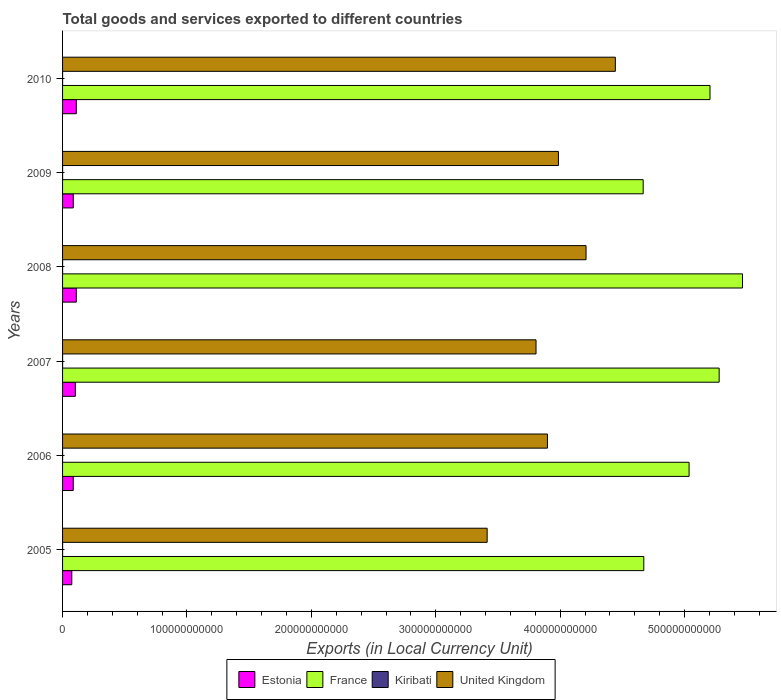How many groups of bars are there?
Give a very brief answer. 6. Are the number of bars per tick equal to the number of legend labels?
Ensure brevity in your answer.  Yes. Are the number of bars on each tick of the Y-axis equal?
Provide a succinct answer. Yes. In how many cases, is the number of bars for a given year not equal to the number of legend labels?
Provide a succinct answer. 0. What is the Amount of goods and services exports in Kiribati in 2009?
Provide a short and direct response. 2.34e+07. Across all years, what is the maximum Amount of goods and services exports in France?
Offer a terse response. 5.47e+11. Across all years, what is the minimum Amount of goods and services exports in Kiribati?
Make the answer very short. 1.52e+07. In which year was the Amount of goods and services exports in United Kingdom maximum?
Give a very brief answer. 2010. What is the total Amount of goods and services exports in Kiribati in the graph?
Make the answer very short. 1.23e+08. What is the difference between the Amount of goods and services exports in United Kingdom in 2005 and that in 2009?
Make the answer very short. -5.73e+1. What is the difference between the Amount of goods and services exports in Kiribati in 2006 and the Amount of goods and services exports in France in 2007?
Give a very brief answer. -5.28e+11. What is the average Amount of goods and services exports in Estonia per year?
Your answer should be compact. 9.49e+09. In the year 2010, what is the difference between the Amount of goods and services exports in Estonia and Amount of goods and services exports in France?
Ensure brevity in your answer.  -5.09e+11. In how many years, is the Amount of goods and services exports in Kiribati greater than 220000000000 LCU?
Offer a very short reply. 0. What is the ratio of the Amount of goods and services exports in Estonia in 2008 to that in 2010?
Offer a terse response. 1. Is the Amount of goods and services exports in United Kingdom in 2007 less than that in 2010?
Keep it short and to the point. Yes. What is the difference between the highest and the second highest Amount of goods and services exports in Kiribati?
Your answer should be very brief. 1.50e+06. What is the difference between the highest and the lowest Amount of goods and services exports in France?
Give a very brief answer. 7.98e+1. In how many years, is the Amount of goods and services exports in United Kingdom greater than the average Amount of goods and services exports in United Kingdom taken over all years?
Your answer should be compact. 3. Is it the case that in every year, the sum of the Amount of goods and services exports in Estonia and Amount of goods and services exports in United Kingdom is greater than the sum of Amount of goods and services exports in Kiribati and Amount of goods and services exports in France?
Make the answer very short. No. What does the 2nd bar from the top in 2006 represents?
Keep it short and to the point. Kiribati. What does the 1st bar from the bottom in 2008 represents?
Make the answer very short. Estonia. How many years are there in the graph?
Make the answer very short. 6. What is the difference between two consecutive major ticks on the X-axis?
Your response must be concise. 1.00e+11. Are the values on the major ticks of X-axis written in scientific E-notation?
Give a very brief answer. No. Does the graph contain any zero values?
Offer a terse response. No. Does the graph contain grids?
Make the answer very short. No. How are the legend labels stacked?
Provide a succinct answer. Horizontal. What is the title of the graph?
Make the answer very short. Total goods and services exported to different countries. What is the label or title of the X-axis?
Keep it short and to the point. Exports (in Local Currency Unit). What is the label or title of the Y-axis?
Your answer should be compact. Years. What is the Exports (in Local Currency Unit) of Estonia in 2005?
Your answer should be very brief. 7.42e+09. What is the Exports (in Local Currency Unit) in France in 2005?
Your answer should be compact. 4.67e+11. What is the Exports (in Local Currency Unit) of Kiribati in 2005?
Your answer should be very brief. 1.96e+07. What is the Exports (in Local Currency Unit) of United Kingdom in 2005?
Provide a succinct answer. 3.41e+11. What is the Exports (in Local Currency Unit) in Estonia in 2006?
Ensure brevity in your answer.  8.58e+09. What is the Exports (in Local Currency Unit) of France in 2006?
Offer a very short reply. 5.04e+11. What is the Exports (in Local Currency Unit) in Kiribati in 2006?
Ensure brevity in your answer.  1.52e+07. What is the Exports (in Local Currency Unit) in United Kingdom in 2006?
Your answer should be very brief. 3.90e+11. What is the Exports (in Local Currency Unit) of Estonia in 2007?
Provide a succinct answer. 1.03e+1. What is the Exports (in Local Currency Unit) of France in 2007?
Your answer should be compact. 5.28e+11. What is the Exports (in Local Currency Unit) in Kiribati in 2007?
Your answer should be very brief. 2.49e+07. What is the Exports (in Local Currency Unit) in United Kingdom in 2007?
Your answer should be very brief. 3.81e+11. What is the Exports (in Local Currency Unit) of Estonia in 2008?
Make the answer very short. 1.10e+1. What is the Exports (in Local Currency Unit) of France in 2008?
Your answer should be compact. 5.47e+11. What is the Exports (in Local Currency Unit) in Kiribati in 2008?
Your answer should be compact. 2.26e+07. What is the Exports (in Local Currency Unit) in United Kingdom in 2008?
Your answer should be very brief. 4.21e+11. What is the Exports (in Local Currency Unit) of Estonia in 2009?
Offer a terse response. 8.60e+09. What is the Exports (in Local Currency Unit) of France in 2009?
Offer a terse response. 4.67e+11. What is the Exports (in Local Currency Unit) in Kiribati in 2009?
Offer a very short reply. 2.34e+07. What is the Exports (in Local Currency Unit) in United Kingdom in 2009?
Your answer should be compact. 3.99e+11. What is the Exports (in Local Currency Unit) of Estonia in 2010?
Keep it short and to the point. 1.10e+1. What is the Exports (in Local Currency Unit) of France in 2010?
Ensure brevity in your answer.  5.20e+11. What is the Exports (in Local Currency Unit) in Kiribati in 2010?
Offer a terse response. 1.78e+07. What is the Exports (in Local Currency Unit) in United Kingdom in 2010?
Offer a terse response. 4.44e+11. Across all years, what is the maximum Exports (in Local Currency Unit) of Estonia?
Keep it short and to the point. 1.10e+1. Across all years, what is the maximum Exports (in Local Currency Unit) in France?
Provide a short and direct response. 5.47e+11. Across all years, what is the maximum Exports (in Local Currency Unit) in Kiribati?
Make the answer very short. 2.49e+07. Across all years, what is the maximum Exports (in Local Currency Unit) of United Kingdom?
Give a very brief answer. 4.44e+11. Across all years, what is the minimum Exports (in Local Currency Unit) of Estonia?
Ensure brevity in your answer.  7.42e+09. Across all years, what is the minimum Exports (in Local Currency Unit) of France?
Ensure brevity in your answer.  4.67e+11. Across all years, what is the minimum Exports (in Local Currency Unit) of Kiribati?
Provide a short and direct response. 1.52e+07. Across all years, what is the minimum Exports (in Local Currency Unit) of United Kingdom?
Offer a terse response. 3.41e+11. What is the total Exports (in Local Currency Unit) of Estonia in the graph?
Provide a short and direct response. 5.70e+1. What is the total Exports (in Local Currency Unit) in France in the graph?
Provide a short and direct response. 3.03e+12. What is the total Exports (in Local Currency Unit) of Kiribati in the graph?
Your answer should be compact. 1.23e+08. What is the total Exports (in Local Currency Unit) in United Kingdom in the graph?
Provide a short and direct response. 2.38e+12. What is the difference between the Exports (in Local Currency Unit) in Estonia in 2005 and that in 2006?
Your answer should be compact. -1.16e+09. What is the difference between the Exports (in Local Currency Unit) in France in 2005 and that in 2006?
Make the answer very short. -3.64e+1. What is the difference between the Exports (in Local Currency Unit) in Kiribati in 2005 and that in 2006?
Your response must be concise. 4.42e+06. What is the difference between the Exports (in Local Currency Unit) of United Kingdom in 2005 and that in 2006?
Offer a very short reply. -4.85e+1. What is the difference between the Exports (in Local Currency Unit) in Estonia in 2005 and that in 2007?
Ensure brevity in your answer.  -2.84e+09. What is the difference between the Exports (in Local Currency Unit) of France in 2005 and that in 2007?
Your answer should be compact. -6.06e+1. What is the difference between the Exports (in Local Currency Unit) in Kiribati in 2005 and that in 2007?
Offer a very short reply. -5.27e+06. What is the difference between the Exports (in Local Currency Unit) of United Kingdom in 2005 and that in 2007?
Make the answer very short. -3.93e+1. What is the difference between the Exports (in Local Currency Unit) of Estonia in 2005 and that in 2008?
Your answer should be compact. -3.61e+09. What is the difference between the Exports (in Local Currency Unit) in France in 2005 and that in 2008?
Your response must be concise. -7.93e+1. What is the difference between the Exports (in Local Currency Unit) of Kiribati in 2005 and that in 2008?
Provide a short and direct response. -3.04e+06. What is the difference between the Exports (in Local Currency Unit) in United Kingdom in 2005 and that in 2008?
Give a very brief answer. -7.95e+1. What is the difference between the Exports (in Local Currency Unit) in Estonia in 2005 and that in 2009?
Ensure brevity in your answer.  -1.18e+09. What is the difference between the Exports (in Local Currency Unit) in France in 2005 and that in 2009?
Your response must be concise. 4.97e+08. What is the difference between the Exports (in Local Currency Unit) in Kiribati in 2005 and that in 2009?
Ensure brevity in your answer.  -3.77e+06. What is the difference between the Exports (in Local Currency Unit) of United Kingdom in 2005 and that in 2009?
Your answer should be compact. -5.73e+1. What is the difference between the Exports (in Local Currency Unit) in Estonia in 2005 and that in 2010?
Your response must be concise. -3.63e+09. What is the difference between the Exports (in Local Currency Unit) of France in 2005 and that in 2010?
Your answer should be very brief. -5.32e+1. What is the difference between the Exports (in Local Currency Unit) of Kiribati in 2005 and that in 2010?
Provide a short and direct response. 1.81e+06. What is the difference between the Exports (in Local Currency Unit) in United Kingdom in 2005 and that in 2010?
Offer a very short reply. -1.03e+11. What is the difference between the Exports (in Local Currency Unit) of Estonia in 2006 and that in 2007?
Your answer should be compact. -1.68e+09. What is the difference between the Exports (in Local Currency Unit) in France in 2006 and that in 2007?
Ensure brevity in your answer.  -2.42e+1. What is the difference between the Exports (in Local Currency Unit) in Kiribati in 2006 and that in 2007?
Provide a succinct answer. -9.69e+06. What is the difference between the Exports (in Local Currency Unit) of United Kingdom in 2006 and that in 2007?
Provide a short and direct response. 9.18e+09. What is the difference between the Exports (in Local Currency Unit) of Estonia in 2006 and that in 2008?
Keep it short and to the point. -2.45e+09. What is the difference between the Exports (in Local Currency Unit) in France in 2006 and that in 2008?
Your response must be concise. -4.29e+1. What is the difference between the Exports (in Local Currency Unit) in Kiribati in 2006 and that in 2008?
Make the answer very short. -7.46e+06. What is the difference between the Exports (in Local Currency Unit) in United Kingdom in 2006 and that in 2008?
Your response must be concise. -3.10e+1. What is the difference between the Exports (in Local Currency Unit) of Estonia in 2006 and that in 2009?
Offer a terse response. -1.66e+07. What is the difference between the Exports (in Local Currency Unit) in France in 2006 and that in 2009?
Offer a very short reply. 3.69e+1. What is the difference between the Exports (in Local Currency Unit) of Kiribati in 2006 and that in 2009?
Offer a very short reply. -8.19e+06. What is the difference between the Exports (in Local Currency Unit) of United Kingdom in 2006 and that in 2009?
Your answer should be compact. -8.82e+09. What is the difference between the Exports (in Local Currency Unit) of Estonia in 2006 and that in 2010?
Keep it short and to the point. -2.46e+09. What is the difference between the Exports (in Local Currency Unit) in France in 2006 and that in 2010?
Your answer should be very brief. -1.68e+1. What is the difference between the Exports (in Local Currency Unit) of Kiribati in 2006 and that in 2010?
Offer a very short reply. -2.62e+06. What is the difference between the Exports (in Local Currency Unit) of United Kingdom in 2006 and that in 2010?
Provide a short and direct response. -5.46e+1. What is the difference between the Exports (in Local Currency Unit) in Estonia in 2007 and that in 2008?
Make the answer very short. -7.66e+08. What is the difference between the Exports (in Local Currency Unit) in France in 2007 and that in 2008?
Provide a short and direct response. -1.88e+1. What is the difference between the Exports (in Local Currency Unit) in Kiribati in 2007 and that in 2008?
Offer a very short reply. 2.23e+06. What is the difference between the Exports (in Local Currency Unit) of United Kingdom in 2007 and that in 2008?
Offer a terse response. -4.02e+1. What is the difference between the Exports (in Local Currency Unit) of Estonia in 2007 and that in 2009?
Make the answer very short. 1.67e+09. What is the difference between the Exports (in Local Currency Unit) in France in 2007 and that in 2009?
Your response must be concise. 6.11e+1. What is the difference between the Exports (in Local Currency Unit) in Kiribati in 2007 and that in 2009?
Give a very brief answer. 1.50e+06. What is the difference between the Exports (in Local Currency Unit) of United Kingdom in 2007 and that in 2009?
Give a very brief answer. -1.80e+1. What is the difference between the Exports (in Local Currency Unit) of Estonia in 2007 and that in 2010?
Your answer should be very brief. -7.82e+08. What is the difference between the Exports (in Local Currency Unit) in France in 2007 and that in 2010?
Provide a short and direct response. 7.36e+09. What is the difference between the Exports (in Local Currency Unit) of Kiribati in 2007 and that in 2010?
Give a very brief answer. 7.08e+06. What is the difference between the Exports (in Local Currency Unit) of United Kingdom in 2007 and that in 2010?
Your answer should be compact. -6.38e+1. What is the difference between the Exports (in Local Currency Unit) of Estonia in 2008 and that in 2009?
Give a very brief answer. 2.43e+09. What is the difference between the Exports (in Local Currency Unit) of France in 2008 and that in 2009?
Offer a very short reply. 7.98e+1. What is the difference between the Exports (in Local Currency Unit) in Kiribati in 2008 and that in 2009?
Provide a short and direct response. -7.25e+05. What is the difference between the Exports (in Local Currency Unit) of United Kingdom in 2008 and that in 2009?
Provide a succinct answer. 2.22e+1. What is the difference between the Exports (in Local Currency Unit) in Estonia in 2008 and that in 2010?
Your response must be concise. -1.58e+07. What is the difference between the Exports (in Local Currency Unit) in France in 2008 and that in 2010?
Ensure brevity in your answer.  2.61e+1. What is the difference between the Exports (in Local Currency Unit) in Kiribati in 2008 and that in 2010?
Your answer should be compact. 4.85e+06. What is the difference between the Exports (in Local Currency Unit) of United Kingdom in 2008 and that in 2010?
Provide a succinct answer. -2.36e+1. What is the difference between the Exports (in Local Currency Unit) in Estonia in 2009 and that in 2010?
Make the answer very short. -2.45e+09. What is the difference between the Exports (in Local Currency Unit) in France in 2009 and that in 2010?
Offer a very short reply. -5.37e+1. What is the difference between the Exports (in Local Currency Unit) in Kiribati in 2009 and that in 2010?
Ensure brevity in your answer.  5.57e+06. What is the difference between the Exports (in Local Currency Unit) in United Kingdom in 2009 and that in 2010?
Make the answer very short. -4.58e+1. What is the difference between the Exports (in Local Currency Unit) of Estonia in 2005 and the Exports (in Local Currency Unit) of France in 2006?
Make the answer very short. -4.96e+11. What is the difference between the Exports (in Local Currency Unit) of Estonia in 2005 and the Exports (in Local Currency Unit) of Kiribati in 2006?
Offer a terse response. 7.41e+09. What is the difference between the Exports (in Local Currency Unit) in Estonia in 2005 and the Exports (in Local Currency Unit) in United Kingdom in 2006?
Your answer should be compact. -3.82e+11. What is the difference between the Exports (in Local Currency Unit) in France in 2005 and the Exports (in Local Currency Unit) in Kiribati in 2006?
Your response must be concise. 4.67e+11. What is the difference between the Exports (in Local Currency Unit) in France in 2005 and the Exports (in Local Currency Unit) in United Kingdom in 2006?
Give a very brief answer. 7.75e+1. What is the difference between the Exports (in Local Currency Unit) in Kiribati in 2005 and the Exports (in Local Currency Unit) in United Kingdom in 2006?
Your answer should be compact. -3.90e+11. What is the difference between the Exports (in Local Currency Unit) in Estonia in 2005 and the Exports (in Local Currency Unit) in France in 2007?
Offer a terse response. -5.20e+11. What is the difference between the Exports (in Local Currency Unit) of Estonia in 2005 and the Exports (in Local Currency Unit) of Kiribati in 2007?
Your response must be concise. 7.40e+09. What is the difference between the Exports (in Local Currency Unit) of Estonia in 2005 and the Exports (in Local Currency Unit) of United Kingdom in 2007?
Your answer should be very brief. -3.73e+11. What is the difference between the Exports (in Local Currency Unit) in France in 2005 and the Exports (in Local Currency Unit) in Kiribati in 2007?
Offer a very short reply. 4.67e+11. What is the difference between the Exports (in Local Currency Unit) in France in 2005 and the Exports (in Local Currency Unit) in United Kingdom in 2007?
Give a very brief answer. 8.66e+1. What is the difference between the Exports (in Local Currency Unit) in Kiribati in 2005 and the Exports (in Local Currency Unit) in United Kingdom in 2007?
Provide a succinct answer. -3.81e+11. What is the difference between the Exports (in Local Currency Unit) in Estonia in 2005 and the Exports (in Local Currency Unit) in France in 2008?
Provide a short and direct response. -5.39e+11. What is the difference between the Exports (in Local Currency Unit) of Estonia in 2005 and the Exports (in Local Currency Unit) of Kiribati in 2008?
Your response must be concise. 7.40e+09. What is the difference between the Exports (in Local Currency Unit) in Estonia in 2005 and the Exports (in Local Currency Unit) in United Kingdom in 2008?
Your answer should be compact. -4.13e+11. What is the difference between the Exports (in Local Currency Unit) in France in 2005 and the Exports (in Local Currency Unit) in Kiribati in 2008?
Provide a succinct answer. 4.67e+11. What is the difference between the Exports (in Local Currency Unit) of France in 2005 and the Exports (in Local Currency Unit) of United Kingdom in 2008?
Offer a very short reply. 4.64e+1. What is the difference between the Exports (in Local Currency Unit) in Kiribati in 2005 and the Exports (in Local Currency Unit) in United Kingdom in 2008?
Offer a terse response. -4.21e+11. What is the difference between the Exports (in Local Currency Unit) of Estonia in 2005 and the Exports (in Local Currency Unit) of France in 2009?
Your response must be concise. -4.59e+11. What is the difference between the Exports (in Local Currency Unit) of Estonia in 2005 and the Exports (in Local Currency Unit) of Kiribati in 2009?
Offer a terse response. 7.40e+09. What is the difference between the Exports (in Local Currency Unit) in Estonia in 2005 and the Exports (in Local Currency Unit) in United Kingdom in 2009?
Keep it short and to the point. -3.91e+11. What is the difference between the Exports (in Local Currency Unit) of France in 2005 and the Exports (in Local Currency Unit) of Kiribati in 2009?
Give a very brief answer. 4.67e+11. What is the difference between the Exports (in Local Currency Unit) in France in 2005 and the Exports (in Local Currency Unit) in United Kingdom in 2009?
Keep it short and to the point. 6.86e+1. What is the difference between the Exports (in Local Currency Unit) of Kiribati in 2005 and the Exports (in Local Currency Unit) of United Kingdom in 2009?
Ensure brevity in your answer.  -3.99e+11. What is the difference between the Exports (in Local Currency Unit) in Estonia in 2005 and the Exports (in Local Currency Unit) in France in 2010?
Make the answer very short. -5.13e+11. What is the difference between the Exports (in Local Currency Unit) of Estonia in 2005 and the Exports (in Local Currency Unit) of Kiribati in 2010?
Make the answer very short. 7.40e+09. What is the difference between the Exports (in Local Currency Unit) in Estonia in 2005 and the Exports (in Local Currency Unit) in United Kingdom in 2010?
Your response must be concise. -4.37e+11. What is the difference between the Exports (in Local Currency Unit) in France in 2005 and the Exports (in Local Currency Unit) in Kiribati in 2010?
Provide a succinct answer. 4.67e+11. What is the difference between the Exports (in Local Currency Unit) in France in 2005 and the Exports (in Local Currency Unit) in United Kingdom in 2010?
Your answer should be very brief. 2.29e+1. What is the difference between the Exports (in Local Currency Unit) of Kiribati in 2005 and the Exports (in Local Currency Unit) of United Kingdom in 2010?
Offer a terse response. -4.44e+11. What is the difference between the Exports (in Local Currency Unit) in Estonia in 2006 and the Exports (in Local Currency Unit) in France in 2007?
Keep it short and to the point. -5.19e+11. What is the difference between the Exports (in Local Currency Unit) in Estonia in 2006 and the Exports (in Local Currency Unit) in Kiribati in 2007?
Keep it short and to the point. 8.56e+09. What is the difference between the Exports (in Local Currency Unit) of Estonia in 2006 and the Exports (in Local Currency Unit) of United Kingdom in 2007?
Your answer should be compact. -3.72e+11. What is the difference between the Exports (in Local Currency Unit) in France in 2006 and the Exports (in Local Currency Unit) in Kiribati in 2007?
Offer a very short reply. 5.04e+11. What is the difference between the Exports (in Local Currency Unit) in France in 2006 and the Exports (in Local Currency Unit) in United Kingdom in 2007?
Provide a short and direct response. 1.23e+11. What is the difference between the Exports (in Local Currency Unit) of Kiribati in 2006 and the Exports (in Local Currency Unit) of United Kingdom in 2007?
Give a very brief answer. -3.81e+11. What is the difference between the Exports (in Local Currency Unit) of Estonia in 2006 and the Exports (in Local Currency Unit) of France in 2008?
Give a very brief answer. -5.38e+11. What is the difference between the Exports (in Local Currency Unit) of Estonia in 2006 and the Exports (in Local Currency Unit) of Kiribati in 2008?
Ensure brevity in your answer.  8.56e+09. What is the difference between the Exports (in Local Currency Unit) of Estonia in 2006 and the Exports (in Local Currency Unit) of United Kingdom in 2008?
Provide a succinct answer. -4.12e+11. What is the difference between the Exports (in Local Currency Unit) in France in 2006 and the Exports (in Local Currency Unit) in Kiribati in 2008?
Your response must be concise. 5.04e+11. What is the difference between the Exports (in Local Currency Unit) in France in 2006 and the Exports (in Local Currency Unit) in United Kingdom in 2008?
Ensure brevity in your answer.  8.28e+1. What is the difference between the Exports (in Local Currency Unit) of Kiribati in 2006 and the Exports (in Local Currency Unit) of United Kingdom in 2008?
Ensure brevity in your answer.  -4.21e+11. What is the difference between the Exports (in Local Currency Unit) of Estonia in 2006 and the Exports (in Local Currency Unit) of France in 2009?
Your answer should be compact. -4.58e+11. What is the difference between the Exports (in Local Currency Unit) of Estonia in 2006 and the Exports (in Local Currency Unit) of Kiribati in 2009?
Provide a short and direct response. 8.56e+09. What is the difference between the Exports (in Local Currency Unit) of Estonia in 2006 and the Exports (in Local Currency Unit) of United Kingdom in 2009?
Offer a very short reply. -3.90e+11. What is the difference between the Exports (in Local Currency Unit) in France in 2006 and the Exports (in Local Currency Unit) in Kiribati in 2009?
Provide a short and direct response. 5.04e+11. What is the difference between the Exports (in Local Currency Unit) of France in 2006 and the Exports (in Local Currency Unit) of United Kingdom in 2009?
Your response must be concise. 1.05e+11. What is the difference between the Exports (in Local Currency Unit) of Kiribati in 2006 and the Exports (in Local Currency Unit) of United Kingdom in 2009?
Your answer should be compact. -3.99e+11. What is the difference between the Exports (in Local Currency Unit) in Estonia in 2006 and the Exports (in Local Currency Unit) in France in 2010?
Your answer should be very brief. -5.12e+11. What is the difference between the Exports (in Local Currency Unit) in Estonia in 2006 and the Exports (in Local Currency Unit) in Kiribati in 2010?
Keep it short and to the point. 8.57e+09. What is the difference between the Exports (in Local Currency Unit) in Estonia in 2006 and the Exports (in Local Currency Unit) in United Kingdom in 2010?
Your response must be concise. -4.36e+11. What is the difference between the Exports (in Local Currency Unit) in France in 2006 and the Exports (in Local Currency Unit) in Kiribati in 2010?
Provide a succinct answer. 5.04e+11. What is the difference between the Exports (in Local Currency Unit) of France in 2006 and the Exports (in Local Currency Unit) of United Kingdom in 2010?
Make the answer very short. 5.93e+1. What is the difference between the Exports (in Local Currency Unit) of Kiribati in 2006 and the Exports (in Local Currency Unit) of United Kingdom in 2010?
Provide a succinct answer. -4.44e+11. What is the difference between the Exports (in Local Currency Unit) of Estonia in 2007 and the Exports (in Local Currency Unit) of France in 2008?
Your answer should be very brief. -5.36e+11. What is the difference between the Exports (in Local Currency Unit) in Estonia in 2007 and the Exports (in Local Currency Unit) in Kiribati in 2008?
Provide a short and direct response. 1.02e+1. What is the difference between the Exports (in Local Currency Unit) of Estonia in 2007 and the Exports (in Local Currency Unit) of United Kingdom in 2008?
Your response must be concise. -4.11e+11. What is the difference between the Exports (in Local Currency Unit) in France in 2007 and the Exports (in Local Currency Unit) in Kiribati in 2008?
Your answer should be compact. 5.28e+11. What is the difference between the Exports (in Local Currency Unit) in France in 2007 and the Exports (in Local Currency Unit) in United Kingdom in 2008?
Make the answer very short. 1.07e+11. What is the difference between the Exports (in Local Currency Unit) in Kiribati in 2007 and the Exports (in Local Currency Unit) in United Kingdom in 2008?
Your answer should be very brief. -4.21e+11. What is the difference between the Exports (in Local Currency Unit) of Estonia in 2007 and the Exports (in Local Currency Unit) of France in 2009?
Make the answer very short. -4.56e+11. What is the difference between the Exports (in Local Currency Unit) in Estonia in 2007 and the Exports (in Local Currency Unit) in Kiribati in 2009?
Your answer should be compact. 1.02e+1. What is the difference between the Exports (in Local Currency Unit) of Estonia in 2007 and the Exports (in Local Currency Unit) of United Kingdom in 2009?
Offer a very short reply. -3.88e+11. What is the difference between the Exports (in Local Currency Unit) in France in 2007 and the Exports (in Local Currency Unit) in Kiribati in 2009?
Ensure brevity in your answer.  5.28e+11. What is the difference between the Exports (in Local Currency Unit) of France in 2007 and the Exports (in Local Currency Unit) of United Kingdom in 2009?
Keep it short and to the point. 1.29e+11. What is the difference between the Exports (in Local Currency Unit) in Kiribati in 2007 and the Exports (in Local Currency Unit) in United Kingdom in 2009?
Your answer should be very brief. -3.99e+11. What is the difference between the Exports (in Local Currency Unit) in Estonia in 2007 and the Exports (in Local Currency Unit) in France in 2010?
Provide a succinct answer. -5.10e+11. What is the difference between the Exports (in Local Currency Unit) of Estonia in 2007 and the Exports (in Local Currency Unit) of Kiribati in 2010?
Make the answer very short. 1.02e+1. What is the difference between the Exports (in Local Currency Unit) in Estonia in 2007 and the Exports (in Local Currency Unit) in United Kingdom in 2010?
Your response must be concise. -4.34e+11. What is the difference between the Exports (in Local Currency Unit) of France in 2007 and the Exports (in Local Currency Unit) of Kiribati in 2010?
Provide a succinct answer. 5.28e+11. What is the difference between the Exports (in Local Currency Unit) in France in 2007 and the Exports (in Local Currency Unit) in United Kingdom in 2010?
Make the answer very short. 8.35e+1. What is the difference between the Exports (in Local Currency Unit) in Kiribati in 2007 and the Exports (in Local Currency Unit) in United Kingdom in 2010?
Ensure brevity in your answer.  -4.44e+11. What is the difference between the Exports (in Local Currency Unit) of Estonia in 2008 and the Exports (in Local Currency Unit) of France in 2009?
Give a very brief answer. -4.56e+11. What is the difference between the Exports (in Local Currency Unit) in Estonia in 2008 and the Exports (in Local Currency Unit) in Kiribati in 2009?
Offer a very short reply. 1.10e+1. What is the difference between the Exports (in Local Currency Unit) of Estonia in 2008 and the Exports (in Local Currency Unit) of United Kingdom in 2009?
Offer a very short reply. -3.88e+11. What is the difference between the Exports (in Local Currency Unit) of France in 2008 and the Exports (in Local Currency Unit) of Kiribati in 2009?
Offer a terse response. 5.47e+11. What is the difference between the Exports (in Local Currency Unit) in France in 2008 and the Exports (in Local Currency Unit) in United Kingdom in 2009?
Your answer should be compact. 1.48e+11. What is the difference between the Exports (in Local Currency Unit) of Kiribati in 2008 and the Exports (in Local Currency Unit) of United Kingdom in 2009?
Offer a very short reply. -3.99e+11. What is the difference between the Exports (in Local Currency Unit) in Estonia in 2008 and the Exports (in Local Currency Unit) in France in 2010?
Your response must be concise. -5.09e+11. What is the difference between the Exports (in Local Currency Unit) in Estonia in 2008 and the Exports (in Local Currency Unit) in Kiribati in 2010?
Offer a terse response. 1.10e+1. What is the difference between the Exports (in Local Currency Unit) of Estonia in 2008 and the Exports (in Local Currency Unit) of United Kingdom in 2010?
Provide a succinct answer. -4.33e+11. What is the difference between the Exports (in Local Currency Unit) of France in 2008 and the Exports (in Local Currency Unit) of Kiribati in 2010?
Your answer should be very brief. 5.47e+11. What is the difference between the Exports (in Local Currency Unit) in France in 2008 and the Exports (in Local Currency Unit) in United Kingdom in 2010?
Make the answer very short. 1.02e+11. What is the difference between the Exports (in Local Currency Unit) in Kiribati in 2008 and the Exports (in Local Currency Unit) in United Kingdom in 2010?
Keep it short and to the point. -4.44e+11. What is the difference between the Exports (in Local Currency Unit) of Estonia in 2009 and the Exports (in Local Currency Unit) of France in 2010?
Keep it short and to the point. -5.12e+11. What is the difference between the Exports (in Local Currency Unit) in Estonia in 2009 and the Exports (in Local Currency Unit) in Kiribati in 2010?
Give a very brief answer. 8.58e+09. What is the difference between the Exports (in Local Currency Unit) in Estonia in 2009 and the Exports (in Local Currency Unit) in United Kingdom in 2010?
Your answer should be very brief. -4.36e+11. What is the difference between the Exports (in Local Currency Unit) in France in 2009 and the Exports (in Local Currency Unit) in Kiribati in 2010?
Provide a succinct answer. 4.67e+11. What is the difference between the Exports (in Local Currency Unit) of France in 2009 and the Exports (in Local Currency Unit) of United Kingdom in 2010?
Provide a succinct answer. 2.24e+1. What is the difference between the Exports (in Local Currency Unit) of Kiribati in 2009 and the Exports (in Local Currency Unit) of United Kingdom in 2010?
Ensure brevity in your answer.  -4.44e+11. What is the average Exports (in Local Currency Unit) in Estonia per year?
Your answer should be very brief. 9.49e+09. What is the average Exports (in Local Currency Unit) of France per year?
Keep it short and to the point. 5.05e+11. What is the average Exports (in Local Currency Unit) in Kiribati per year?
Make the answer very short. 2.06e+07. What is the average Exports (in Local Currency Unit) of United Kingdom per year?
Offer a very short reply. 3.96e+11. In the year 2005, what is the difference between the Exports (in Local Currency Unit) in Estonia and Exports (in Local Currency Unit) in France?
Make the answer very short. -4.60e+11. In the year 2005, what is the difference between the Exports (in Local Currency Unit) in Estonia and Exports (in Local Currency Unit) in Kiribati?
Offer a terse response. 7.40e+09. In the year 2005, what is the difference between the Exports (in Local Currency Unit) of Estonia and Exports (in Local Currency Unit) of United Kingdom?
Offer a terse response. -3.34e+11. In the year 2005, what is the difference between the Exports (in Local Currency Unit) of France and Exports (in Local Currency Unit) of Kiribati?
Offer a very short reply. 4.67e+11. In the year 2005, what is the difference between the Exports (in Local Currency Unit) of France and Exports (in Local Currency Unit) of United Kingdom?
Keep it short and to the point. 1.26e+11. In the year 2005, what is the difference between the Exports (in Local Currency Unit) in Kiribati and Exports (in Local Currency Unit) in United Kingdom?
Provide a succinct answer. -3.41e+11. In the year 2006, what is the difference between the Exports (in Local Currency Unit) of Estonia and Exports (in Local Currency Unit) of France?
Your response must be concise. -4.95e+11. In the year 2006, what is the difference between the Exports (in Local Currency Unit) of Estonia and Exports (in Local Currency Unit) of Kiribati?
Provide a succinct answer. 8.57e+09. In the year 2006, what is the difference between the Exports (in Local Currency Unit) of Estonia and Exports (in Local Currency Unit) of United Kingdom?
Give a very brief answer. -3.81e+11. In the year 2006, what is the difference between the Exports (in Local Currency Unit) in France and Exports (in Local Currency Unit) in Kiribati?
Make the answer very short. 5.04e+11. In the year 2006, what is the difference between the Exports (in Local Currency Unit) of France and Exports (in Local Currency Unit) of United Kingdom?
Ensure brevity in your answer.  1.14e+11. In the year 2006, what is the difference between the Exports (in Local Currency Unit) in Kiribati and Exports (in Local Currency Unit) in United Kingdom?
Provide a succinct answer. -3.90e+11. In the year 2007, what is the difference between the Exports (in Local Currency Unit) in Estonia and Exports (in Local Currency Unit) in France?
Your response must be concise. -5.18e+11. In the year 2007, what is the difference between the Exports (in Local Currency Unit) in Estonia and Exports (in Local Currency Unit) in Kiribati?
Make the answer very short. 1.02e+1. In the year 2007, what is the difference between the Exports (in Local Currency Unit) of Estonia and Exports (in Local Currency Unit) of United Kingdom?
Keep it short and to the point. -3.70e+11. In the year 2007, what is the difference between the Exports (in Local Currency Unit) of France and Exports (in Local Currency Unit) of Kiribati?
Offer a terse response. 5.28e+11. In the year 2007, what is the difference between the Exports (in Local Currency Unit) in France and Exports (in Local Currency Unit) in United Kingdom?
Make the answer very short. 1.47e+11. In the year 2007, what is the difference between the Exports (in Local Currency Unit) in Kiribati and Exports (in Local Currency Unit) in United Kingdom?
Keep it short and to the point. -3.81e+11. In the year 2008, what is the difference between the Exports (in Local Currency Unit) of Estonia and Exports (in Local Currency Unit) of France?
Your answer should be very brief. -5.36e+11. In the year 2008, what is the difference between the Exports (in Local Currency Unit) in Estonia and Exports (in Local Currency Unit) in Kiribati?
Offer a very short reply. 1.10e+1. In the year 2008, what is the difference between the Exports (in Local Currency Unit) of Estonia and Exports (in Local Currency Unit) of United Kingdom?
Give a very brief answer. -4.10e+11. In the year 2008, what is the difference between the Exports (in Local Currency Unit) of France and Exports (in Local Currency Unit) of Kiribati?
Your answer should be compact. 5.47e+11. In the year 2008, what is the difference between the Exports (in Local Currency Unit) of France and Exports (in Local Currency Unit) of United Kingdom?
Your response must be concise. 1.26e+11. In the year 2008, what is the difference between the Exports (in Local Currency Unit) of Kiribati and Exports (in Local Currency Unit) of United Kingdom?
Provide a short and direct response. -4.21e+11. In the year 2009, what is the difference between the Exports (in Local Currency Unit) of Estonia and Exports (in Local Currency Unit) of France?
Keep it short and to the point. -4.58e+11. In the year 2009, what is the difference between the Exports (in Local Currency Unit) of Estonia and Exports (in Local Currency Unit) of Kiribati?
Your answer should be compact. 8.58e+09. In the year 2009, what is the difference between the Exports (in Local Currency Unit) in Estonia and Exports (in Local Currency Unit) in United Kingdom?
Offer a very short reply. -3.90e+11. In the year 2009, what is the difference between the Exports (in Local Currency Unit) of France and Exports (in Local Currency Unit) of Kiribati?
Ensure brevity in your answer.  4.67e+11. In the year 2009, what is the difference between the Exports (in Local Currency Unit) in France and Exports (in Local Currency Unit) in United Kingdom?
Offer a very short reply. 6.81e+1. In the year 2009, what is the difference between the Exports (in Local Currency Unit) of Kiribati and Exports (in Local Currency Unit) of United Kingdom?
Provide a short and direct response. -3.99e+11. In the year 2010, what is the difference between the Exports (in Local Currency Unit) in Estonia and Exports (in Local Currency Unit) in France?
Offer a terse response. -5.09e+11. In the year 2010, what is the difference between the Exports (in Local Currency Unit) in Estonia and Exports (in Local Currency Unit) in Kiribati?
Offer a terse response. 1.10e+1. In the year 2010, what is the difference between the Exports (in Local Currency Unit) of Estonia and Exports (in Local Currency Unit) of United Kingdom?
Ensure brevity in your answer.  -4.33e+11. In the year 2010, what is the difference between the Exports (in Local Currency Unit) in France and Exports (in Local Currency Unit) in Kiribati?
Make the answer very short. 5.20e+11. In the year 2010, what is the difference between the Exports (in Local Currency Unit) of France and Exports (in Local Currency Unit) of United Kingdom?
Your response must be concise. 7.61e+1. In the year 2010, what is the difference between the Exports (in Local Currency Unit) in Kiribati and Exports (in Local Currency Unit) in United Kingdom?
Your answer should be compact. -4.44e+11. What is the ratio of the Exports (in Local Currency Unit) in Estonia in 2005 to that in 2006?
Your answer should be very brief. 0.86. What is the ratio of the Exports (in Local Currency Unit) of France in 2005 to that in 2006?
Make the answer very short. 0.93. What is the ratio of the Exports (in Local Currency Unit) in Kiribati in 2005 to that in 2006?
Keep it short and to the point. 1.29. What is the ratio of the Exports (in Local Currency Unit) of United Kingdom in 2005 to that in 2006?
Provide a short and direct response. 0.88. What is the ratio of the Exports (in Local Currency Unit) of Estonia in 2005 to that in 2007?
Ensure brevity in your answer.  0.72. What is the ratio of the Exports (in Local Currency Unit) in France in 2005 to that in 2007?
Your answer should be very brief. 0.89. What is the ratio of the Exports (in Local Currency Unit) of Kiribati in 2005 to that in 2007?
Your answer should be very brief. 0.79. What is the ratio of the Exports (in Local Currency Unit) of United Kingdom in 2005 to that in 2007?
Your answer should be compact. 0.9. What is the ratio of the Exports (in Local Currency Unit) of Estonia in 2005 to that in 2008?
Your response must be concise. 0.67. What is the ratio of the Exports (in Local Currency Unit) of France in 2005 to that in 2008?
Your answer should be very brief. 0.85. What is the ratio of the Exports (in Local Currency Unit) in Kiribati in 2005 to that in 2008?
Ensure brevity in your answer.  0.87. What is the ratio of the Exports (in Local Currency Unit) in United Kingdom in 2005 to that in 2008?
Your answer should be very brief. 0.81. What is the ratio of the Exports (in Local Currency Unit) of Estonia in 2005 to that in 2009?
Your answer should be very brief. 0.86. What is the ratio of the Exports (in Local Currency Unit) of France in 2005 to that in 2009?
Make the answer very short. 1. What is the ratio of the Exports (in Local Currency Unit) of Kiribati in 2005 to that in 2009?
Provide a short and direct response. 0.84. What is the ratio of the Exports (in Local Currency Unit) in United Kingdom in 2005 to that in 2009?
Provide a short and direct response. 0.86. What is the ratio of the Exports (in Local Currency Unit) of Estonia in 2005 to that in 2010?
Your answer should be compact. 0.67. What is the ratio of the Exports (in Local Currency Unit) of France in 2005 to that in 2010?
Give a very brief answer. 0.9. What is the ratio of the Exports (in Local Currency Unit) in Kiribati in 2005 to that in 2010?
Provide a short and direct response. 1.1. What is the ratio of the Exports (in Local Currency Unit) in United Kingdom in 2005 to that in 2010?
Your response must be concise. 0.77. What is the ratio of the Exports (in Local Currency Unit) of Estonia in 2006 to that in 2007?
Offer a terse response. 0.84. What is the ratio of the Exports (in Local Currency Unit) in France in 2006 to that in 2007?
Offer a terse response. 0.95. What is the ratio of the Exports (in Local Currency Unit) in Kiribati in 2006 to that in 2007?
Offer a very short reply. 0.61. What is the ratio of the Exports (in Local Currency Unit) of United Kingdom in 2006 to that in 2007?
Offer a very short reply. 1.02. What is the ratio of the Exports (in Local Currency Unit) in Estonia in 2006 to that in 2008?
Offer a very short reply. 0.78. What is the ratio of the Exports (in Local Currency Unit) in France in 2006 to that in 2008?
Ensure brevity in your answer.  0.92. What is the ratio of the Exports (in Local Currency Unit) in Kiribati in 2006 to that in 2008?
Provide a succinct answer. 0.67. What is the ratio of the Exports (in Local Currency Unit) of United Kingdom in 2006 to that in 2008?
Your answer should be very brief. 0.93. What is the ratio of the Exports (in Local Currency Unit) of Estonia in 2006 to that in 2009?
Your answer should be very brief. 1. What is the ratio of the Exports (in Local Currency Unit) of France in 2006 to that in 2009?
Your answer should be very brief. 1.08. What is the ratio of the Exports (in Local Currency Unit) of Kiribati in 2006 to that in 2009?
Offer a very short reply. 0.65. What is the ratio of the Exports (in Local Currency Unit) of United Kingdom in 2006 to that in 2009?
Give a very brief answer. 0.98. What is the ratio of the Exports (in Local Currency Unit) in Estonia in 2006 to that in 2010?
Your answer should be very brief. 0.78. What is the ratio of the Exports (in Local Currency Unit) in France in 2006 to that in 2010?
Keep it short and to the point. 0.97. What is the ratio of the Exports (in Local Currency Unit) in Kiribati in 2006 to that in 2010?
Provide a short and direct response. 0.85. What is the ratio of the Exports (in Local Currency Unit) in United Kingdom in 2006 to that in 2010?
Ensure brevity in your answer.  0.88. What is the ratio of the Exports (in Local Currency Unit) of Estonia in 2007 to that in 2008?
Offer a very short reply. 0.93. What is the ratio of the Exports (in Local Currency Unit) of France in 2007 to that in 2008?
Ensure brevity in your answer.  0.97. What is the ratio of the Exports (in Local Currency Unit) in Kiribati in 2007 to that in 2008?
Your answer should be compact. 1.1. What is the ratio of the Exports (in Local Currency Unit) of United Kingdom in 2007 to that in 2008?
Offer a very short reply. 0.9. What is the ratio of the Exports (in Local Currency Unit) of Estonia in 2007 to that in 2009?
Your answer should be compact. 1.19. What is the ratio of the Exports (in Local Currency Unit) of France in 2007 to that in 2009?
Your response must be concise. 1.13. What is the ratio of the Exports (in Local Currency Unit) in Kiribati in 2007 to that in 2009?
Give a very brief answer. 1.06. What is the ratio of the Exports (in Local Currency Unit) of United Kingdom in 2007 to that in 2009?
Offer a terse response. 0.95. What is the ratio of the Exports (in Local Currency Unit) in Estonia in 2007 to that in 2010?
Your answer should be compact. 0.93. What is the ratio of the Exports (in Local Currency Unit) of France in 2007 to that in 2010?
Your answer should be very brief. 1.01. What is the ratio of the Exports (in Local Currency Unit) of Kiribati in 2007 to that in 2010?
Provide a succinct answer. 1.4. What is the ratio of the Exports (in Local Currency Unit) in United Kingdom in 2007 to that in 2010?
Your answer should be compact. 0.86. What is the ratio of the Exports (in Local Currency Unit) of Estonia in 2008 to that in 2009?
Offer a terse response. 1.28. What is the ratio of the Exports (in Local Currency Unit) in France in 2008 to that in 2009?
Provide a succinct answer. 1.17. What is the ratio of the Exports (in Local Currency Unit) in Kiribati in 2008 to that in 2009?
Make the answer very short. 0.97. What is the ratio of the Exports (in Local Currency Unit) in United Kingdom in 2008 to that in 2009?
Provide a short and direct response. 1.06. What is the ratio of the Exports (in Local Currency Unit) in Estonia in 2008 to that in 2010?
Ensure brevity in your answer.  1. What is the ratio of the Exports (in Local Currency Unit) of France in 2008 to that in 2010?
Provide a succinct answer. 1.05. What is the ratio of the Exports (in Local Currency Unit) of Kiribati in 2008 to that in 2010?
Your answer should be very brief. 1.27. What is the ratio of the Exports (in Local Currency Unit) in United Kingdom in 2008 to that in 2010?
Offer a very short reply. 0.95. What is the ratio of the Exports (in Local Currency Unit) of Estonia in 2009 to that in 2010?
Offer a terse response. 0.78. What is the ratio of the Exports (in Local Currency Unit) of France in 2009 to that in 2010?
Offer a terse response. 0.9. What is the ratio of the Exports (in Local Currency Unit) in Kiribati in 2009 to that in 2010?
Provide a succinct answer. 1.31. What is the ratio of the Exports (in Local Currency Unit) of United Kingdom in 2009 to that in 2010?
Provide a succinct answer. 0.9. What is the difference between the highest and the second highest Exports (in Local Currency Unit) in Estonia?
Your answer should be compact. 1.58e+07. What is the difference between the highest and the second highest Exports (in Local Currency Unit) in France?
Keep it short and to the point. 1.88e+1. What is the difference between the highest and the second highest Exports (in Local Currency Unit) of Kiribati?
Offer a terse response. 1.50e+06. What is the difference between the highest and the second highest Exports (in Local Currency Unit) of United Kingdom?
Make the answer very short. 2.36e+1. What is the difference between the highest and the lowest Exports (in Local Currency Unit) in Estonia?
Provide a succinct answer. 3.63e+09. What is the difference between the highest and the lowest Exports (in Local Currency Unit) of France?
Your answer should be compact. 7.98e+1. What is the difference between the highest and the lowest Exports (in Local Currency Unit) in Kiribati?
Offer a very short reply. 9.69e+06. What is the difference between the highest and the lowest Exports (in Local Currency Unit) in United Kingdom?
Provide a short and direct response. 1.03e+11. 